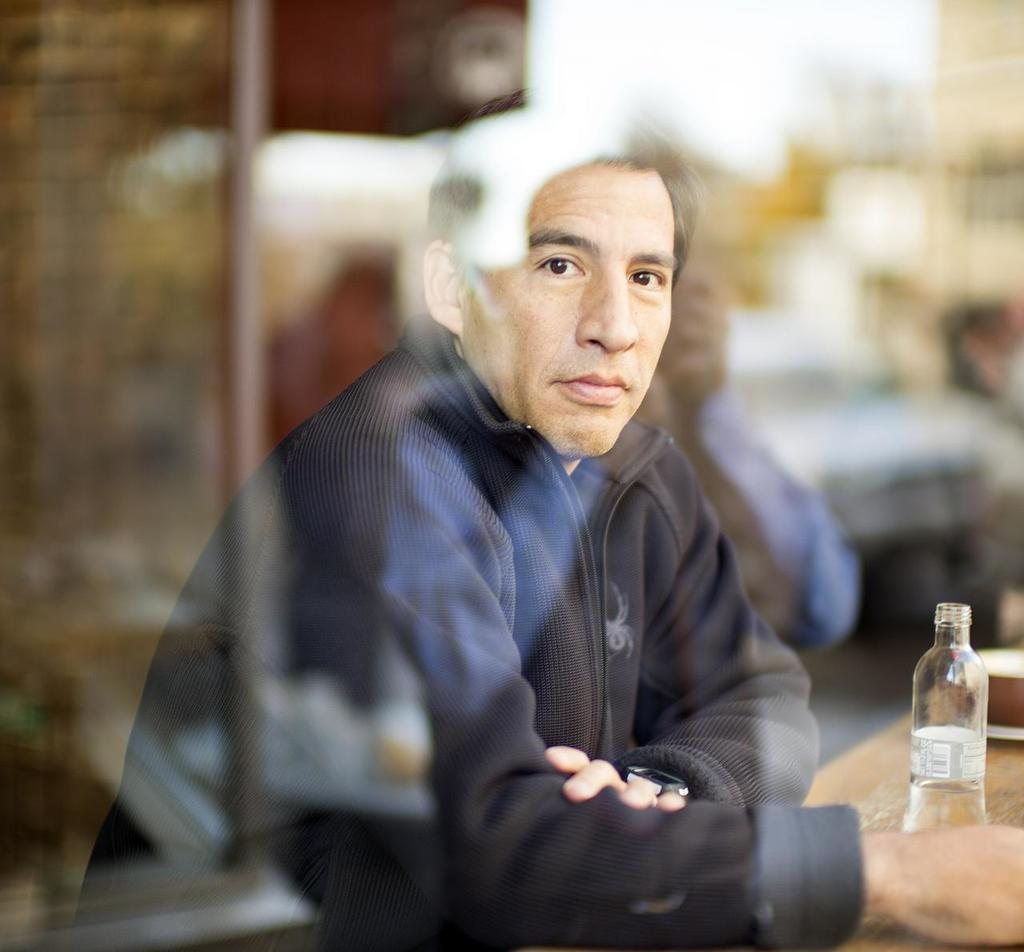Who is in the image? There is a man in the image. What is the man wearing? The man is wearing a black jacket. Where is the man located in the image? The man is sitting in front of a table. What items can be seen on the table? There is a water bottle and a bowl on the table. How would you describe the background of the image? The background of the image is blurred. What type of station does the man use to rub fuel on his jacket in the image? There is no station, rubbing, or fuel present in the image. 